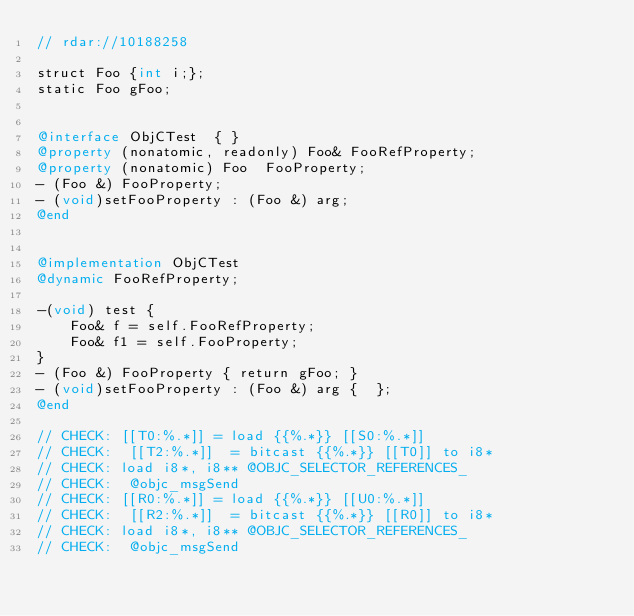Convert code to text. <code><loc_0><loc_0><loc_500><loc_500><_ObjectiveC_>// rdar://10188258

struct Foo {int i;};
static Foo gFoo;


@interface ObjCTest  { }
@property (nonatomic, readonly) Foo& FooRefProperty;
@property (nonatomic) Foo  FooProperty;
- (Foo &) FooProperty;
- (void)setFooProperty : (Foo &) arg;
@end


@implementation ObjCTest
@dynamic FooRefProperty;

-(void) test {
    Foo& f = self.FooRefProperty;
    Foo& f1 = self.FooProperty;
}
- (Foo &) FooProperty { return gFoo; }
- (void)setFooProperty : (Foo &) arg {  };
@end

// CHECK: [[T0:%.*]] = load {{%.*}} [[S0:%.*]]
// CHECK:  [[T2:%.*]]  = bitcast {{%.*}} [[T0]] to i8*
// CHECK: load i8*, i8** @OBJC_SELECTOR_REFERENCES_
// CHECK:  @objc_msgSend
// CHECK: [[R0:%.*]] = load {{%.*}} [[U0:%.*]]
// CHECK:  [[R2:%.*]]  = bitcast {{%.*}} [[R0]] to i8*
// CHECK: load i8*, i8** @OBJC_SELECTOR_REFERENCES_
// CHECK:  @objc_msgSend

</code> 